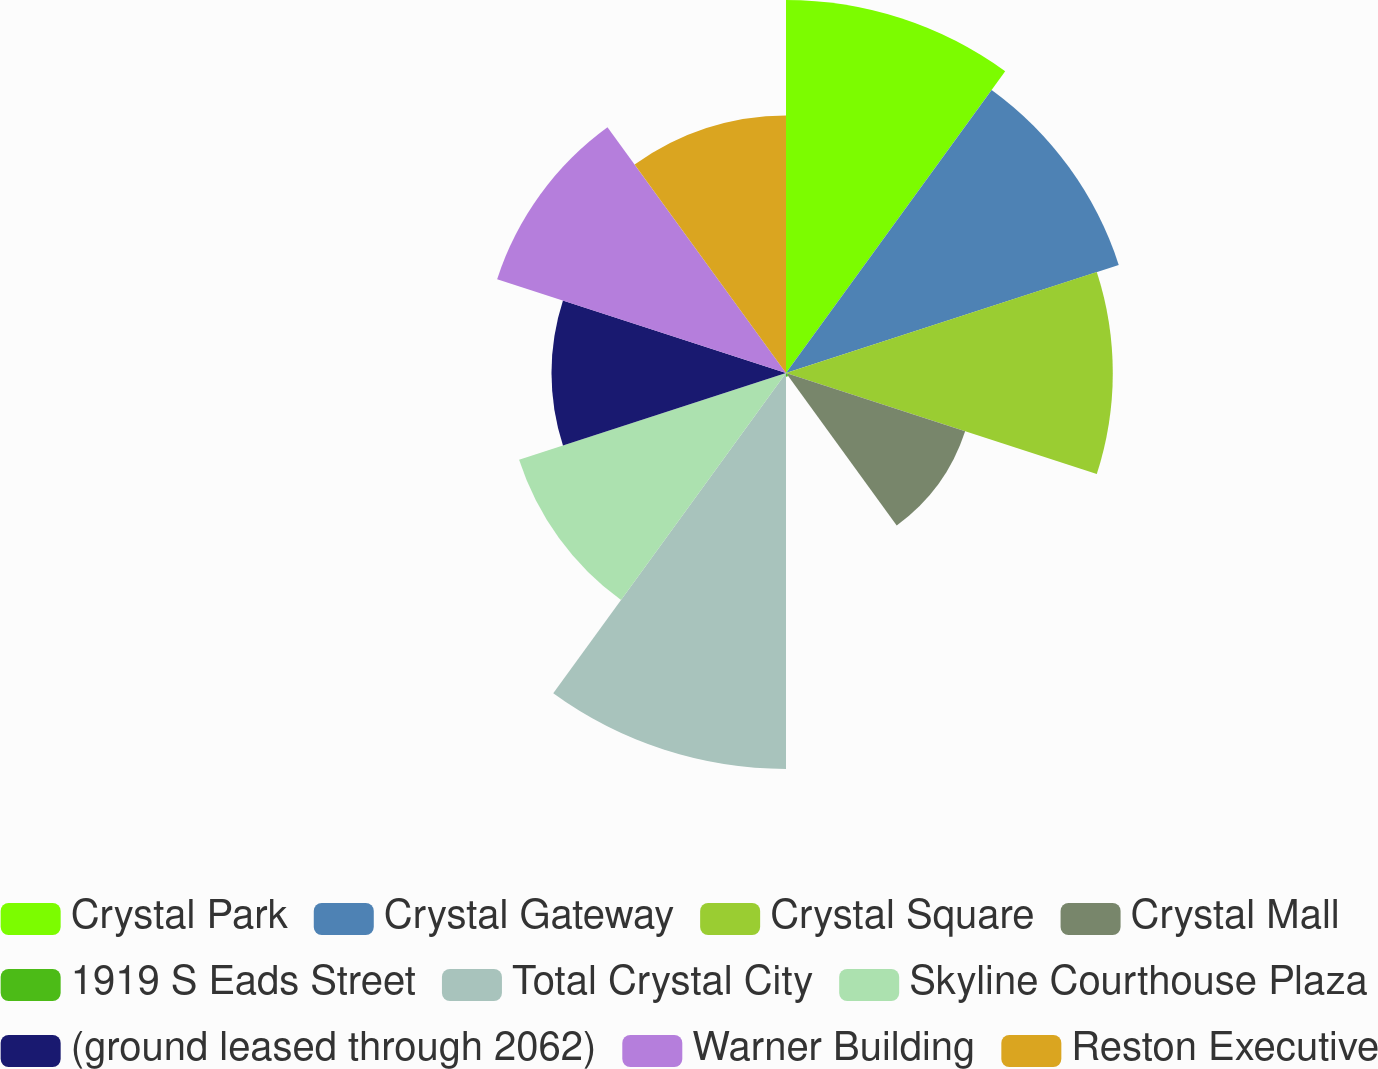Convert chart. <chart><loc_0><loc_0><loc_500><loc_500><pie_chart><fcel>Crystal Park<fcel>Crystal Gateway<fcel>Crystal Square<fcel>Crystal Mall<fcel>1919 S Eads Street<fcel>Total Crystal City<fcel>Skyline Courthouse Plaza<fcel>(ground leased through 2062)<fcel>Warner Building<fcel>Reston Executive<nl><fcel>13.74%<fcel>12.89%<fcel>12.04%<fcel>6.94%<fcel>0.14%<fcel>14.59%<fcel>10.34%<fcel>8.64%<fcel>11.19%<fcel>9.49%<nl></chart> 